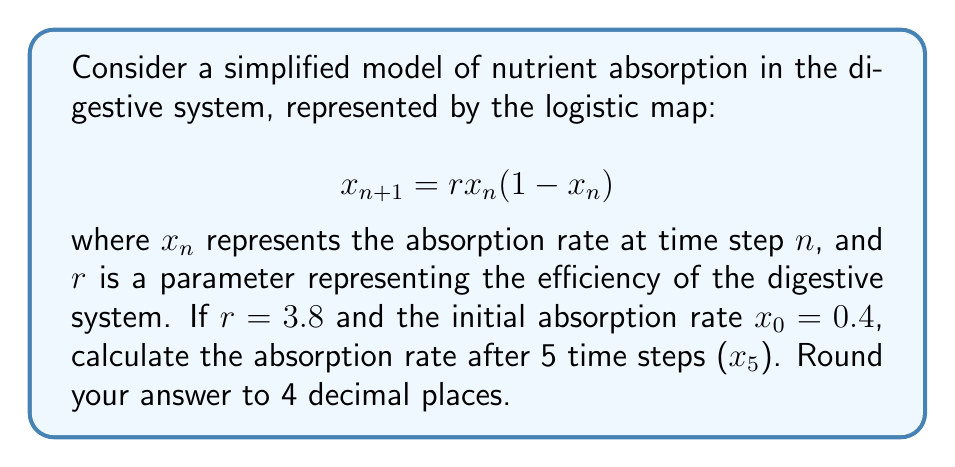What is the answer to this math problem? To solve this problem, we need to iterate the logistic map equation for 5 time steps:

1) First iteration ($n = 0$ to $n = 1$):
   $$x_1 = 3.8 \cdot 0.4 \cdot (1-0.4) = 3.8 \cdot 0.4 \cdot 0.6 = 0.912$$

2) Second iteration ($n = 1$ to $n = 2$):
   $$x_2 = 3.8 \cdot 0.912 \cdot (1-0.912) = 3.8 \cdot 0.912 \cdot 0.088 = 0.3050304$$

3) Third iteration ($n = 2$ to $n = 3$):
   $$x_3 = 3.8 \cdot 0.3050304 \cdot (1-0.3050304) = 0.8066573$$

4) Fourth iteration ($n = 3$ to $n = 4$):
   $$x_4 = 3.8 \cdot 0.8066573 \cdot (1-0.8066573) = 0.5934845$$

5) Fifth iteration ($n = 4$ to $n = 5$):
   $$x_5 = 3.8 \cdot 0.5934845 \cdot (1-0.5934845) = 0.9179458$$

Rounding to 4 decimal places, we get 0.9179.
Answer: 0.9179 